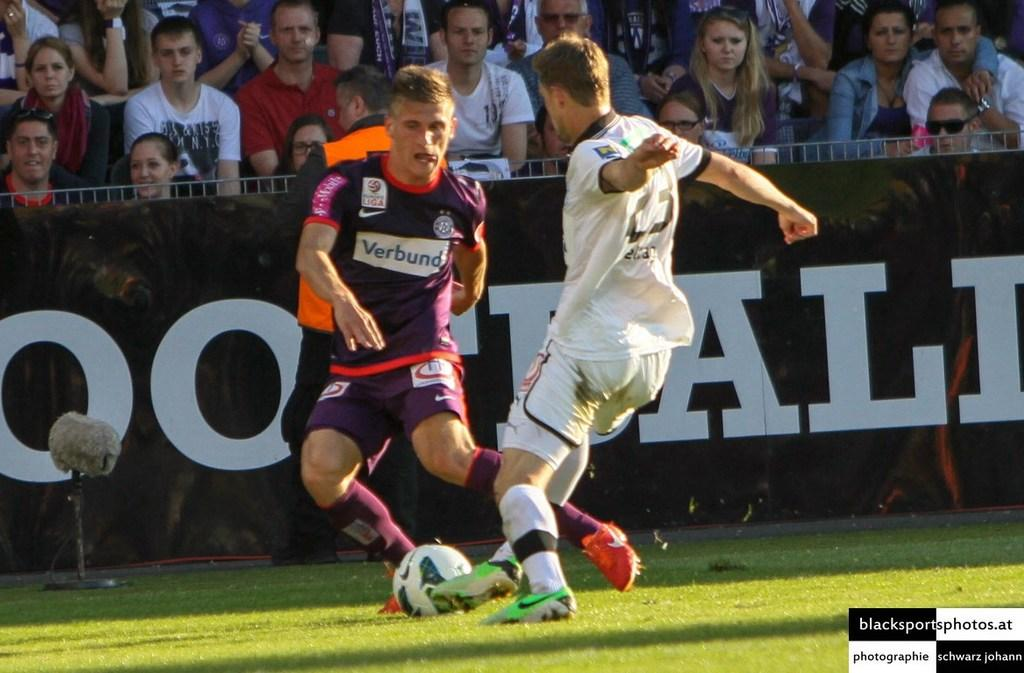<image>
Present a compact description of the photo's key features. Two soccer players on the soccer field playing soccer 